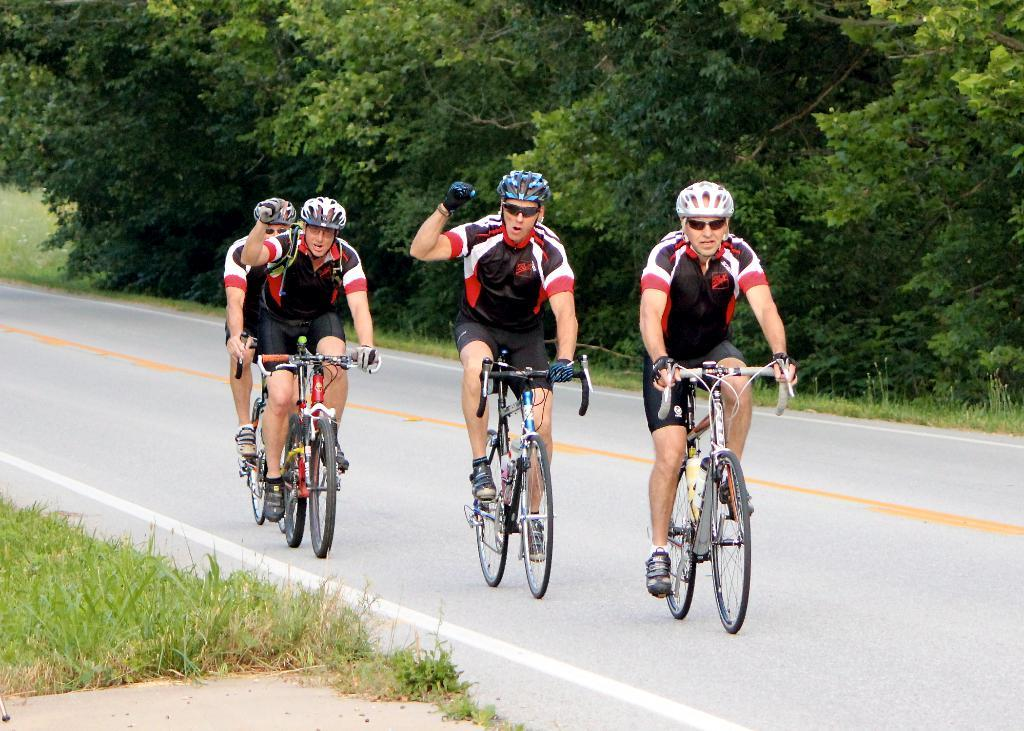What are the people in the image doing? The people in the image are sitting on bicycles. What safety precaution are the people taking? The people are wearing helmets. What can be seen in the background of the image? There are trees, a road, and grass visible in the background of the image. What type of leaf can be seen falling from the trees in the image? There is no leaf falling from the trees in the image; it only shows trees, a road, and grass in the background. Can you tell me how many toads are sitting on the bicycles in the image? There are no toads present in the image; it only features people sitting on bicycles. 